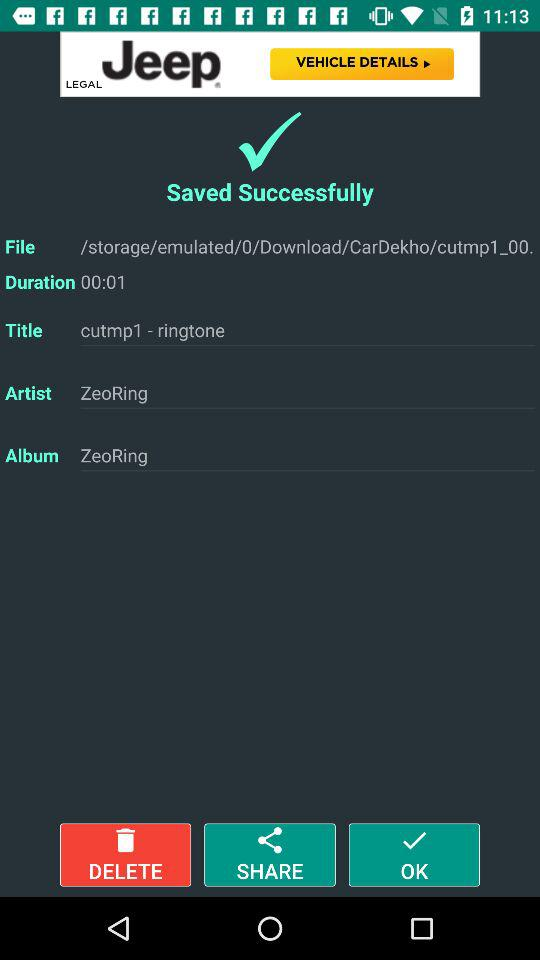What is the duration of the album? The duration of the album is 1 second. 